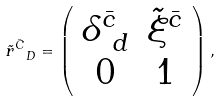<formula> <loc_0><loc_0><loc_500><loc_500>\tilde { r } ^ { \bar { C } } _ { \ D } = \left ( \begin{array} { c c } \delta ^ { \bar { c } } _ { \ d } & \tilde { \xi } ^ { \bar { c } } \\ 0 & 1 \end{array} \right ) ,</formula> 